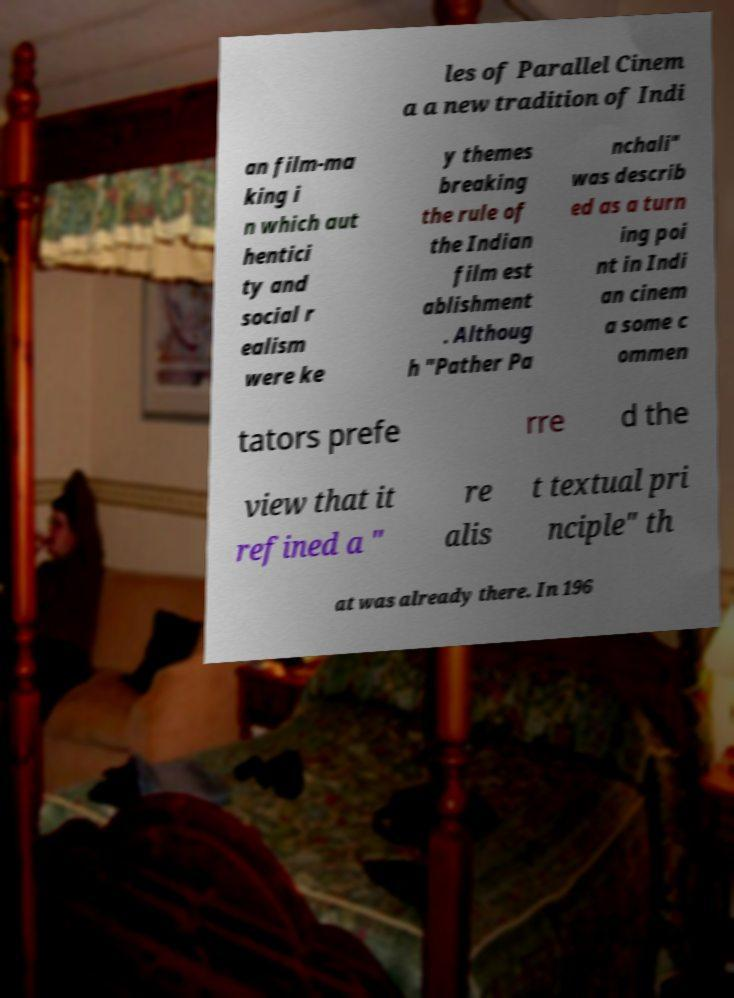Could you extract and type out the text from this image? les of Parallel Cinem a a new tradition of Indi an film-ma king i n which aut hentici ty and social r ealism were ke y themes breaking the rule of the Indian film est ablishment . Althoug h "Pather Pa nchali" was describ ed as a turn ing poi nt in Indi an cinem a some c ommen tators prefe rre d the view that it refined a " re alis t textual pri nciple" th at was already there. In 196 